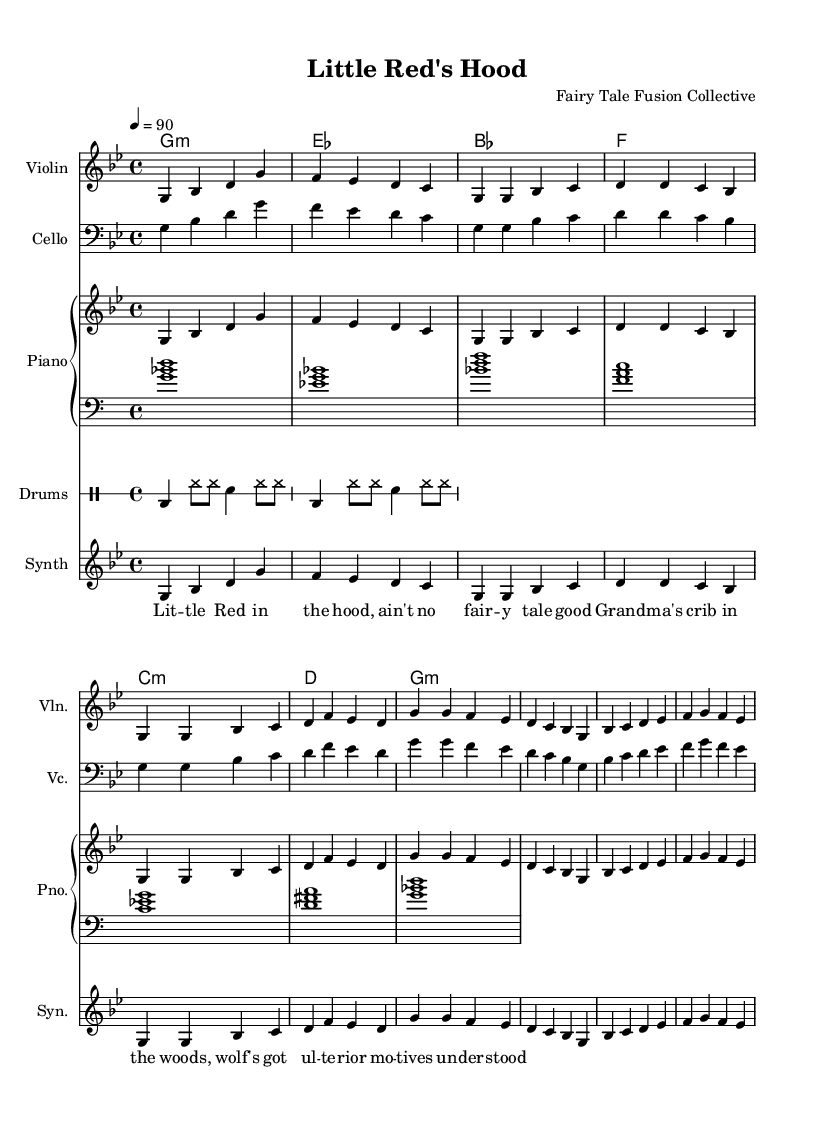What is the key signature of this music? The key signature is G minor, which has two flats (B flat and E flat). You can identify the key signature by looking at the beginning of the staff where the flat symbols are indicated.
Answer: G minor What is the time signature of the piece? The time signature is 4/4, which means there are four beats in each measure and the quarter note gets one beat. This can be seen at the start of the music above the staff.
Answer: 4/4 What is the tempo marking for this piece? The tempo marking is 90 beats per minute, indicated by the tempo directive written at the beginning of the score. This gives performers a clear idea of the intended speed of the music.
Answer: 90 How many measures are in the verse section? The verse section contains four measures. By counting the horizontal dividing lines on the staff where the melody for the verse is written, we can determine that there are four distinct measures allocated for this part.
Answer: Four What instrument plays the melody? The melody is played by the Violin, which is listed at the beginning of the staff indicating the specific instrument associated with that line.
Answer: Violin What unique musical style is featured in this piece? The unique musical style featured in this piece is a fusion of classical and hip hop elements, as suggested by the combination of traditional instruments like the Violin and modern rhythmic features such as the drum patterns and contemporary lyrics that reflect a fairy tale narrative.
Answer: Classical-hip hop fusion How are the lyrics incorporated into the music? The lyrics are integrated with the melody voiced by the synthesizer, as indicated in the score where the lyrics are aligned with the notes, suggesting that vocal performance accompanies the musical lines.
Answer: Aligned with the melody 